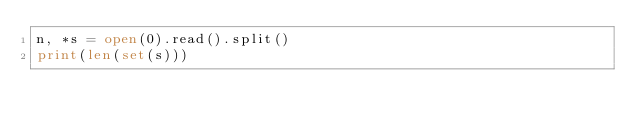<code> <loc_0><loc_0><loc_500><loc_500><_Python_>n, *s = open(0).read().split()
print(len(set(s)))</code> 